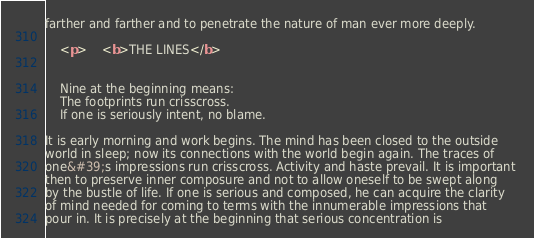<code> <loc_0><loc_0><loc_500><loc_500><_HTML_>farther and farther and to penetrate the nature of man ever more deeply. 
		
	<p>	<b>THE LINES</b>

	
	Nine at the beginning means:
	The footprints run crisscross.
	If one is seriously intent, no blame.

It is early morning and work begins. The mind has been closed to the outside 
world in sleep; now its connections with the world begin again. The traces of 
one&#39;s impressions run crisscross. Activity and haste prevail. It is important 
then to preserve inner composure and not to allow oneself to be swept along 
by the bustle of life. If one is serious and composed, he can acquire the clarity 
of mind needed for coming to terms with the innumerable impressions that 
pour in. It is precisely at the beginning that serious concentration is </code> 